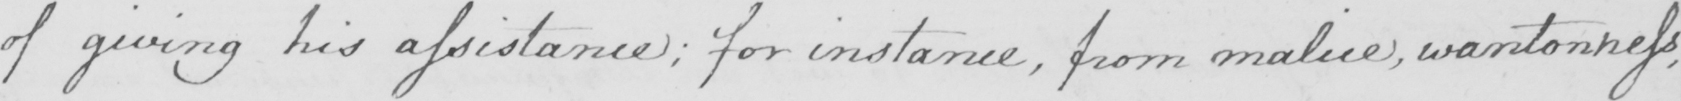Can you tell me what this handwritten text says? of giving his assistance ; for instance , from malice , wantonness , 